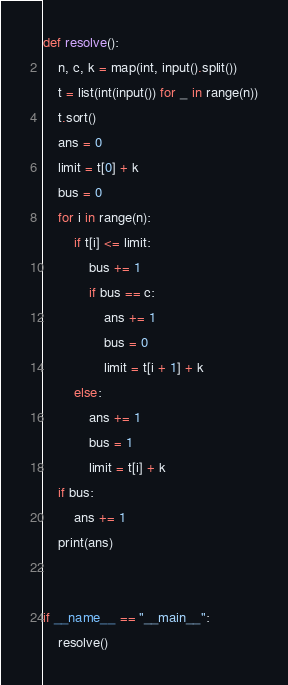<code> <loc_0><loc_0><loc_500><loc_500><_Python_>def resolve():
    n, c, k = map(int, input().split())
    t = list(int(input()) for _ in range(n))
    t.sort()
    ans = 0
    limit = t[0] + k
    bus = 0
    for i in range(n):
        if t[i] <= limit:
            bus += 1
            if bus == c:
                ans += 1
                bus = 0
                limit = t[i + 1] + k
        else:
            ans += 1
            bus = 1
            limit = t[i] + k
    if bus:
        ans += 1
    print(ans)


if __name__ == "__main__":
    resolve()
</code> 